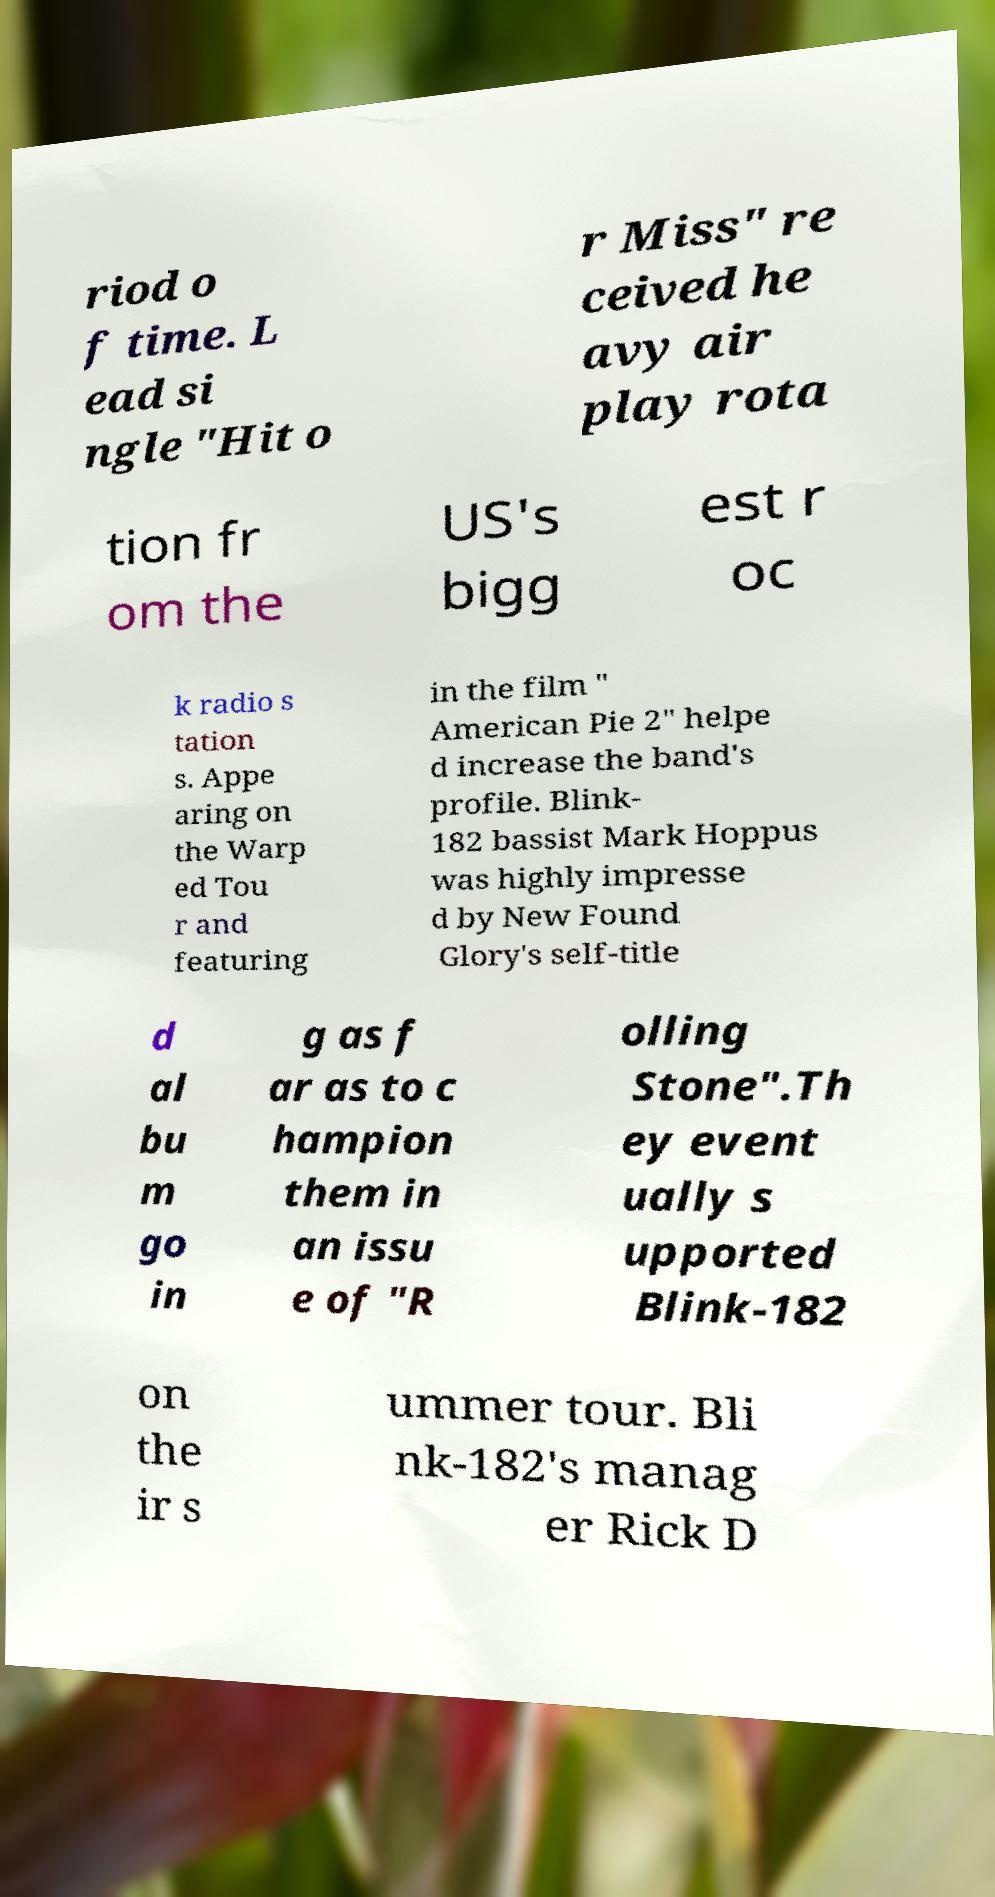There's text embedded in this image that I need extracted. Can you transcribe it verbatim? riod o f time. L ead si ngle "Hit o r Miss" re ceived he avy air play rota tion fr om the US's bigg est r oc k radio s tation s. Appe aring on the Warp ed Tou r and featuring in the film " American Pie 2" helpe d increase the band's profile. Blink- 182 bassist Mark Hoppus was highly impresse d by New Found Glory's self-title d al bu m go in g as f ar as to c hampion them in an issu e of "R olling Stone".Th ey event ually s upported Blink-182 on the ir s ummer tour. Bli nk-182's manag er Rick D 